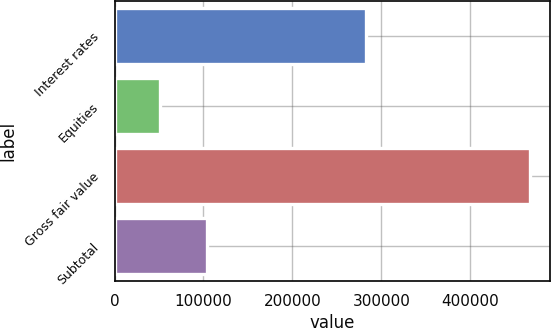Convert chart to OTSL. <chart><loc_0><loc_0><loc_500><loc_500><bar_chart><fcel>Interest rates<fcel>Equities<fcel>Gross fair value<fcel>Subtotal<nl><fcel>283262<fcel>51287<fcel>466863<fcel>103703<nl></chart> 